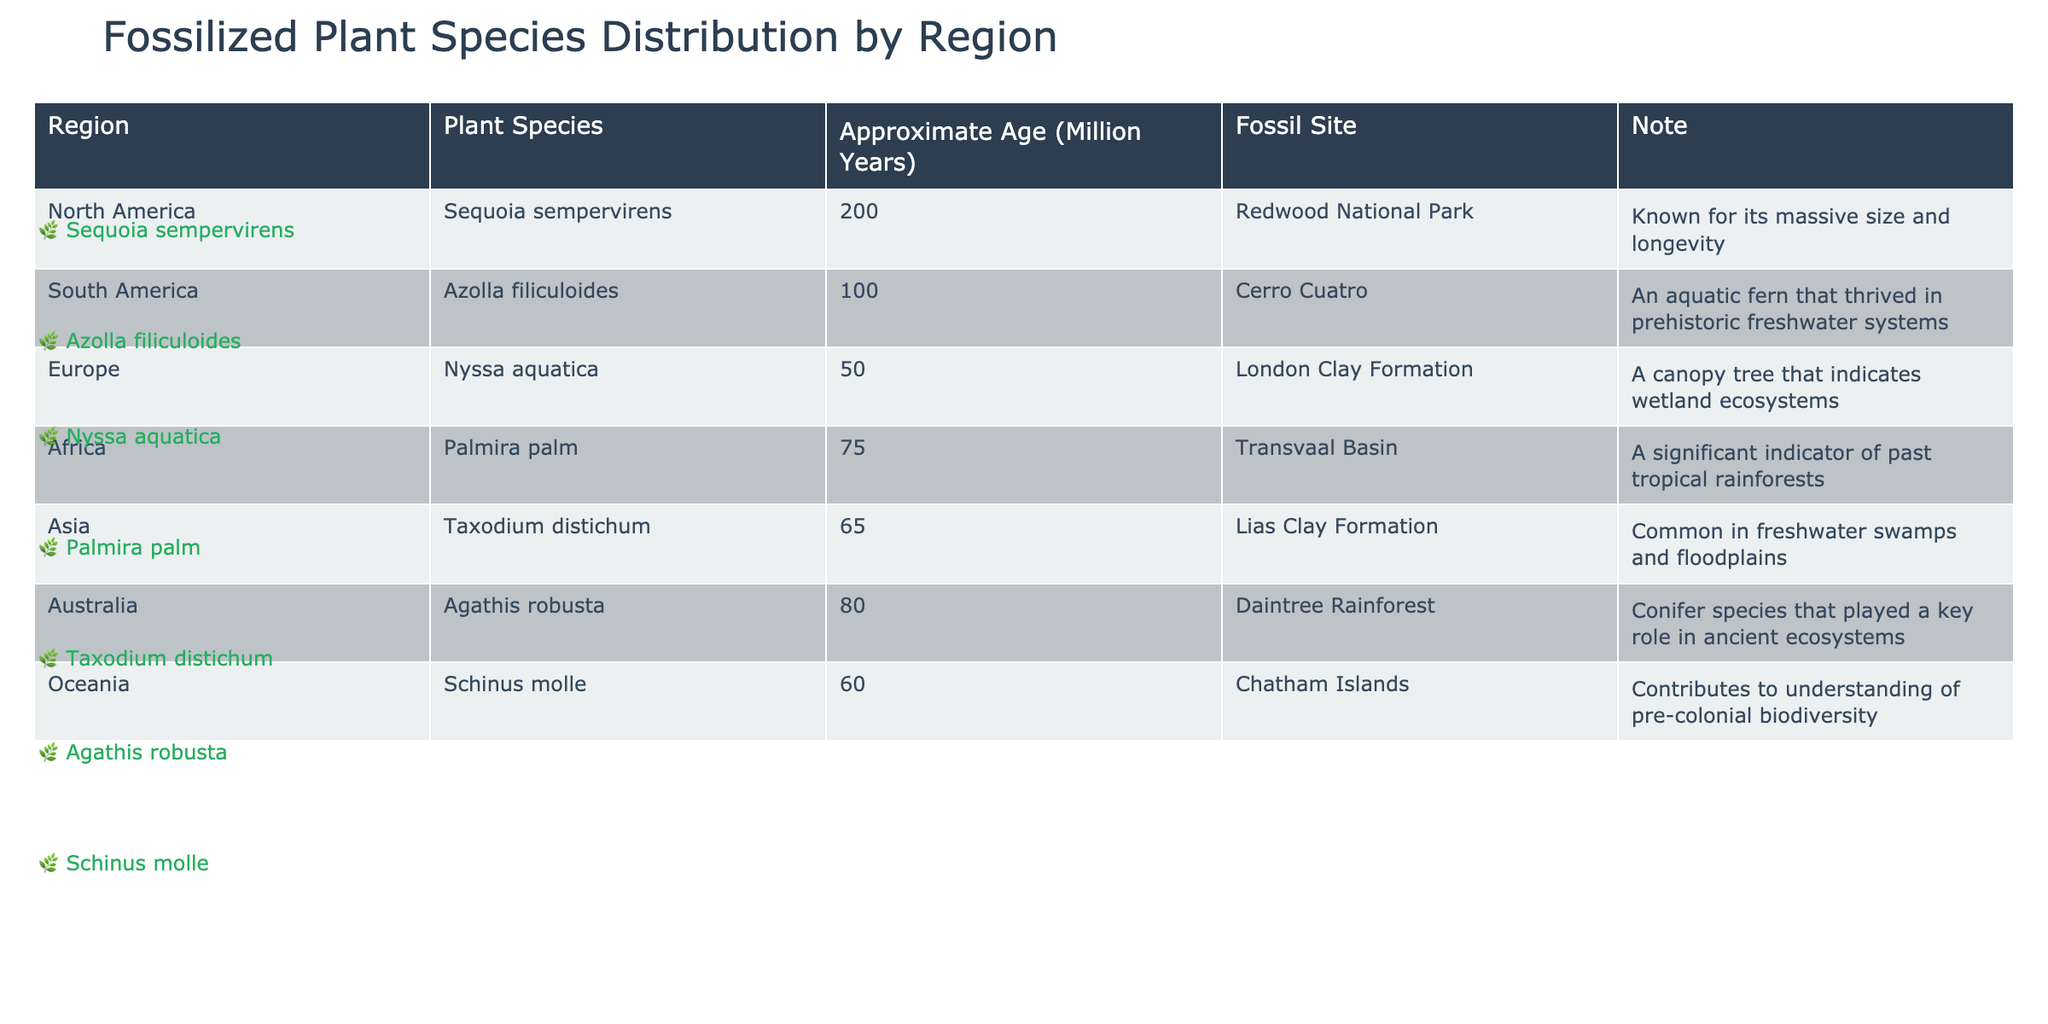What is the approximate age of the plant species Sequoia sempervirens? The table states that Sequoia sempervirens is approximately 200 million years old.
Answer: 200 million years Which plant species is found in Africa? According to the table, the plant species found in Africa is Palmira palm.
Answer: Palmira palm How many plant species listed in the table are approximately 100 million years old? The only plant species with an approximate age of 100 million years is Azolla filiculoides. Thus, there is 1 such species.
Answer: 1 Is Nyssa aquatica known for its role in wetland ecosystems? Yes, the note for Nyssa aquatica indicates that it is a canopy tree that suggests wetland ecosystems.
Answer: Yes Which region has the oldest plant species listed? Upon reviewing the ages, North America’s Sequoia sempervirens at 200 million years old is the oldest among the listed species.
Answer: North America What is the average approximate age of the plant species from South America and Europe? South America’s Azolla filiculoides is 100 million years old and Europe’s Nyssa aquatica is 50 million years old. The average is (100 + 50) / 2 = 75 million years.
Answer: 75 million years Are there any plant species with an approximate age of over 80 million years? Yes, Sequoia sempervirens (200 million years) and Palmira palm (over 75 million years) indicate there is one species older than 80 million years.
Answer: Yes Name a region and its corresponding plant species that indicate flooded ecosystems. Asia is the region, and Taxodium distichum is the species that indicates freshwater swamps and floodplains.
Answer: Asia, Taxodium distichum Is there any plant species listed that is common to both North America and Europe? No, the table lists distinct plant species for each region without any overlap.
Answer: No How does the approximate age of Agathis robusta compare to Taxodium distichum? Agathis robusta (80 million years) is older than Taxodium distichum (65 million years) by 15 million years.
Answer: Older by 15 million years 